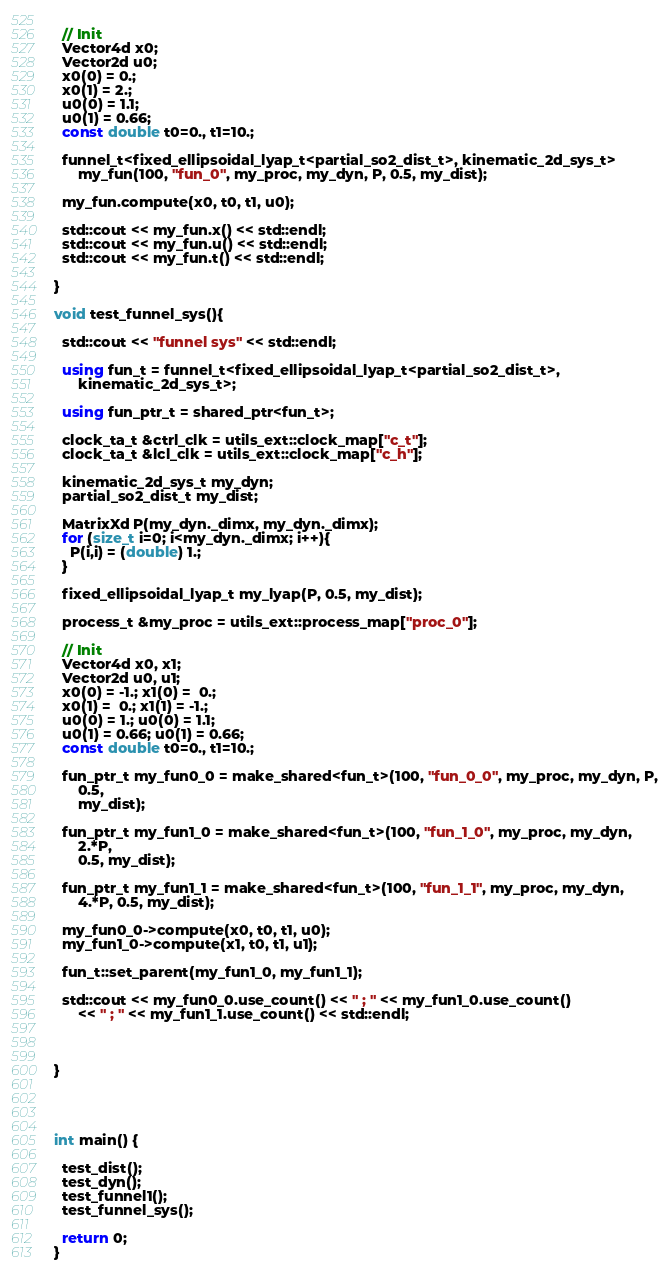Convert code to text. <code><loc_0><loc_0><loc_500><loc_500><_C++_>  
  // Init
  Vector4d x0;
  Vector2d u0;
  x0(0) = 0.;
  x0(1) = 2.;
  u0(0) = 1.1;
  u0(1) = 0.66;
  const double t0=0., t1=10.;
  
  funnel_t<fixed_ellipsoidal_lyap_t<partial_so2_dist_t>, kinematic_2d_sys_t>
      my_fun(100, "fun_0", my_proc, my_dyn, P, 0.5, my_dist);
  
  my_fun.compute(x0, t0, t1, u0);
  
  std::cout << my_fun.x() << std::endl;
  std::cout << my_fun.u() << std::endl;
  std::cout << my_fun.t() << std::endl;
  
}

void test_funnel_sys(){
  
  std::cout << "funnel sys" << std::endl;
  
  using fun_t = funnel_t<fixed_ellipsoidal_lyap_t<partial_so2_dist_t>,
      kinematic_2d_sys_t>;
  
  using fun_ptr_t = shared_ptr<fun_t>;
  
  clock_ta_t &ctrl_clk = utils_ext::clock_map["c_t"];
  clock_ta_t &lcl_clk = utils_ext::clock_map["c_h"];
  
  kinematic_2d_sys_t my_dyn;
  partial_so2_dist_t my_dist;
  
  MatrixXd P(my_dyn._dimx, my_dyn._dimx);
  for (size_t i=0; i<my_dyn._dimx; i++){
    P(i,i) = (double) 1.;
  }
  
  fixed_ellipsoidal_lyap_t my_lyap(P, 0.5, my_dist);
  
  process_t &my_proc = utils_ext::process_map["proc_0"];
  
  // Init
  Vector4d x0, x1;
  Vector2d u0, u1;
  x0(0) = -1.; x1(0) =  0.;
  x0(1) =  0.; x1(1) = -1.;
  u0(0) = 1.; u0(0) = 1.1;
  u0(1) = 0.66; u0(1) = 0.66;
  const double t0=0., t1=10.;
  
  fun_ptr_t my_fun0_0 = make_shared<fun_t>(100, "fun_0_0", my_proc, my_dyn, P,
      0.5,
      my_dist);
  
  fun_ptr_t my_fun1_0 = make_shared<fun_t>(100, "fun_1_0", my_proc, my_dyn,
      2.*P,
      0.5, my_dist);
  
  fun_ptr_t my_fun1_1 = make_shared<fun_t>(100, "fun_1_1", my_proc, my_dyn,
      4.*P, 0.5, my_dist);
  
  my_fun0_0->compute(x0, t0, t1, u0);
  my_fun1_0->compute(x1, t0, t1, u1);
  
  fun_t::set_parent(my_fun1_0, my_fun1_1);
  
  std::cout << my_fun0_0.use_count() << " ; " << my_fun1_0.use_count()
      << " ; " << my_fun1_1.use_count() << std::endl;
  
  
  
}




int main() {
  
  test_dist();
  test_dyn();
  test_funnel1();
  test_funnel_sys();
  
  return 0;
}</code> 